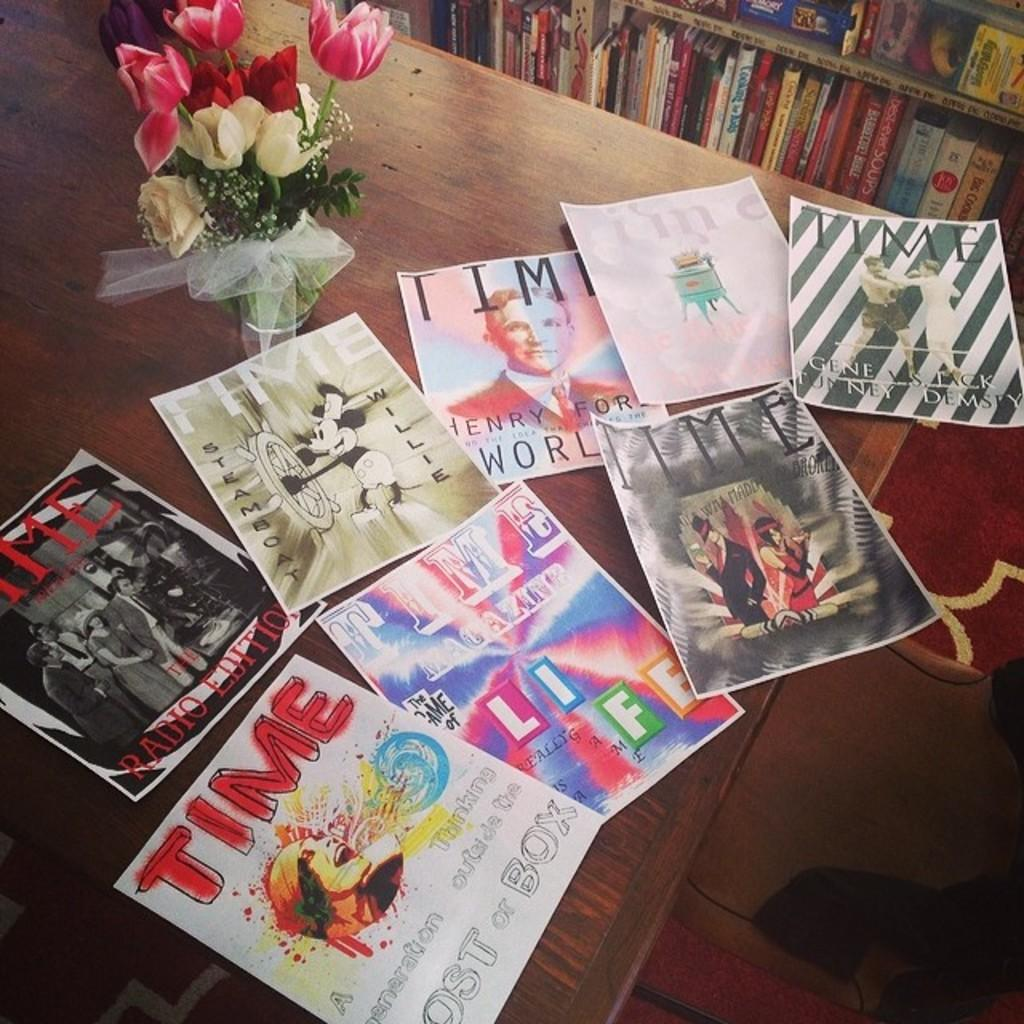<image>
Summarize the visual content of the image. Scans of old Time Magazine covers lay on a table in front of a vase of tulips 